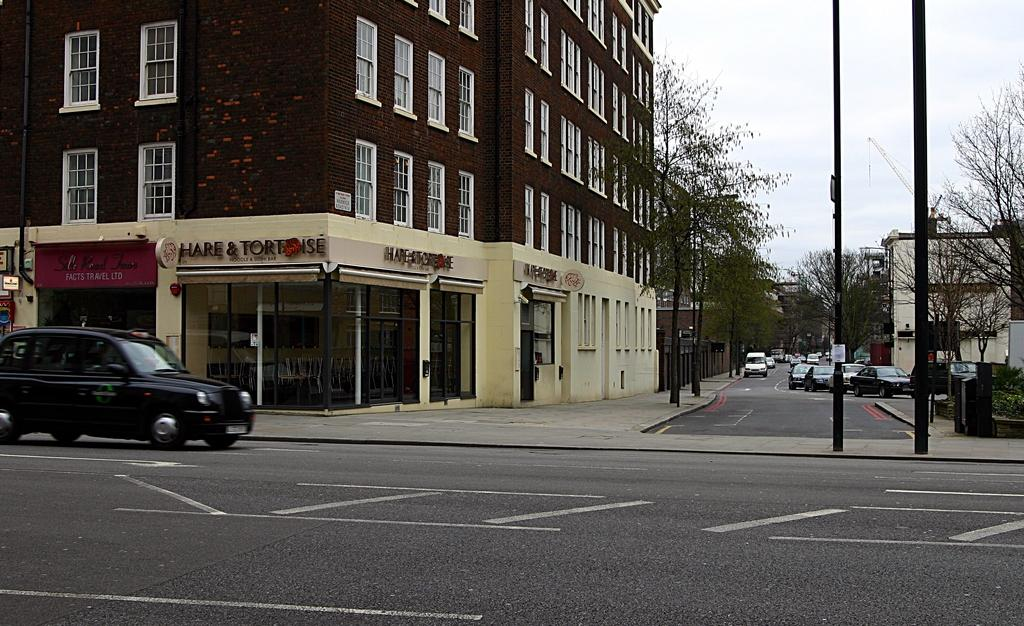<image>
Create a compact narrative representing the image presented. Hare & Tortoise shop sits on the counter of the street with a car parked out front. 